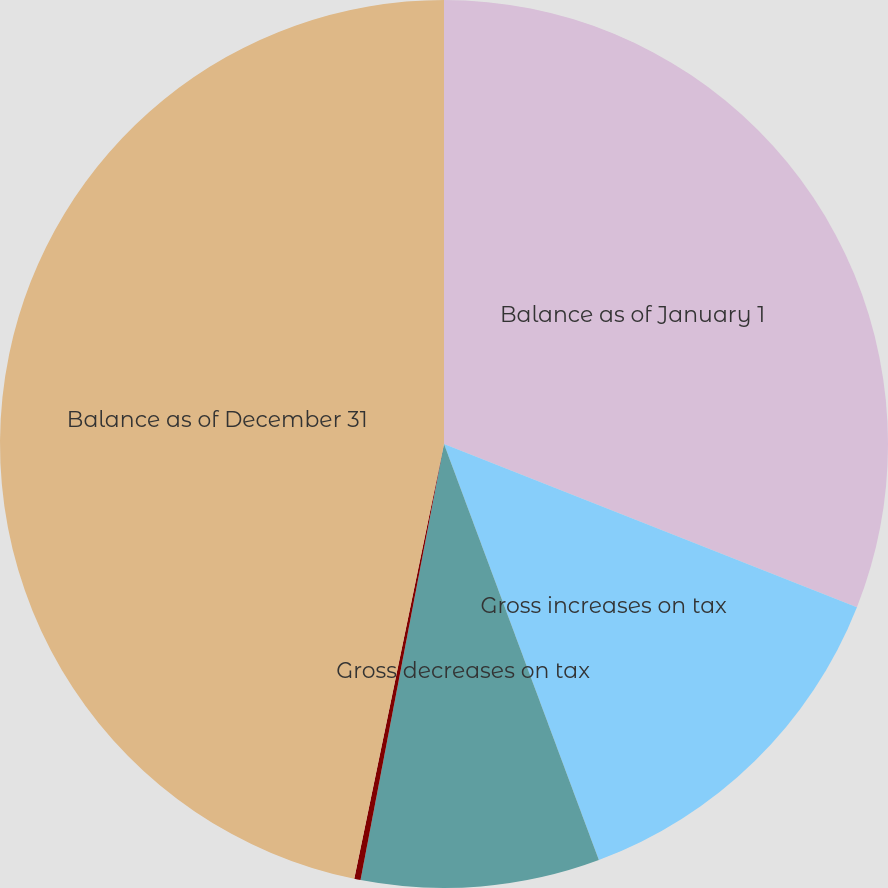<chart> <loc_0><loc_0><loc_500><loc_500><pie_chart><fcel>Balance as of January 1<fcel>Gross increases on tax<fcel>Gross decreases on tax<fcel>Lapseof statute of limitations<fcel>Balance as of December 31<nl><fcel>30.99%<fcel>13.34%<fcel>8.68%<fcel>0.23%<fcel>46.76%<nl></chart> 